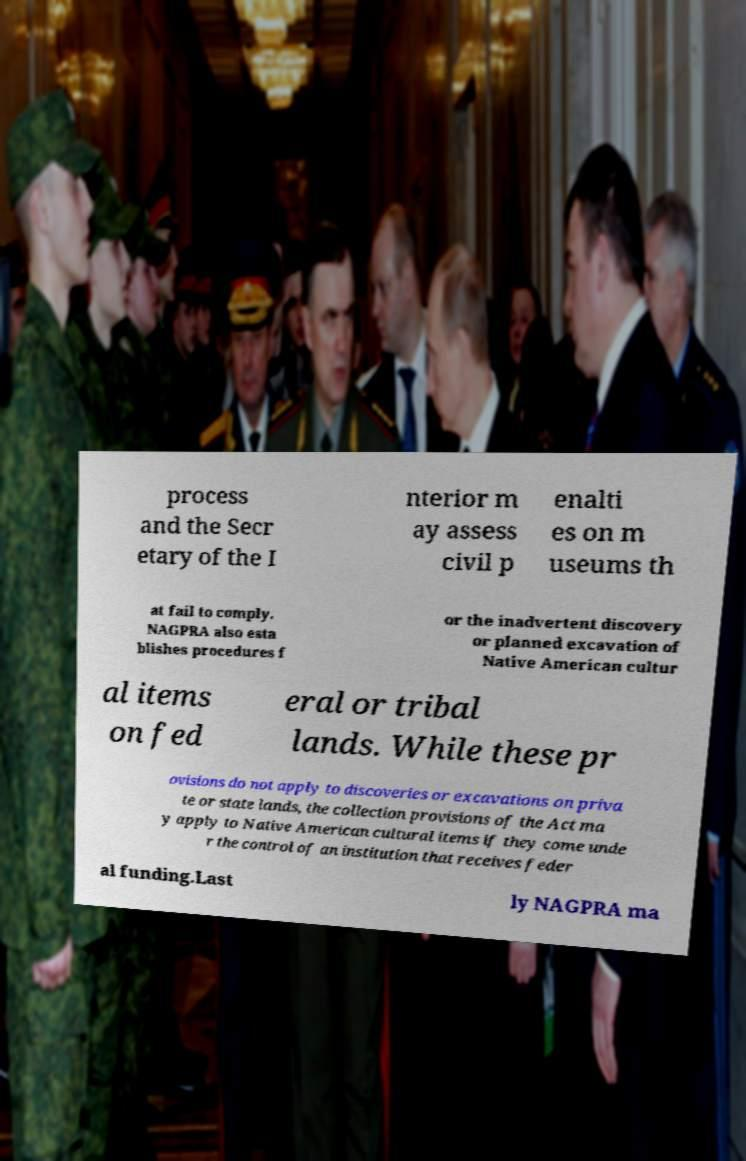Can you accurately transcribe the text from the provided image for me? process and the Secr etary of the I nterior m ay assess civil p enalti es on m useums th at fail to comply. NAGPRA also esta blishes procedures f or the inadvertent discovery or planned excavation of Native American cultur al items on fed eral or tribal lands. While these pr ovisions do not apply to discoveries or excavations on priva te or state lands, the collection provisions of the Act ma y apply to Native American cultural items if they come unde r the control of an institution that receives feder al funding.Last ly NAGPRA ma 